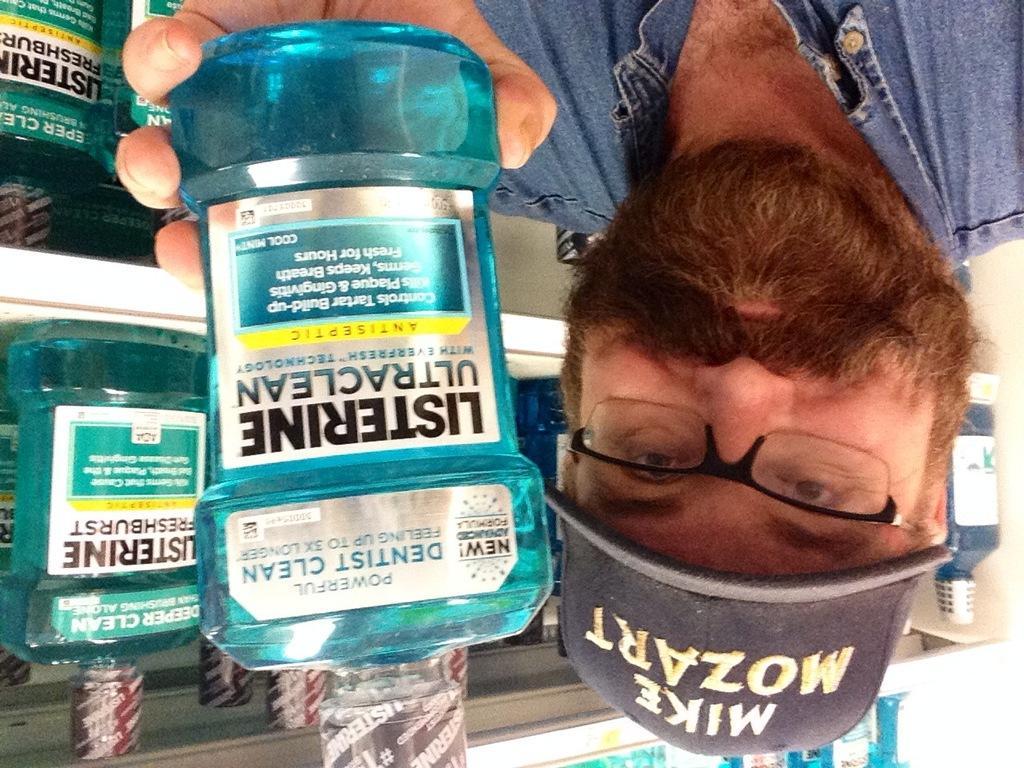Describe this image in one or two sentences. In the foreground of the picture there is a person holding a plastic bottle, behind him there are bottles in racks. The person is wearing spectacles and a cap. 